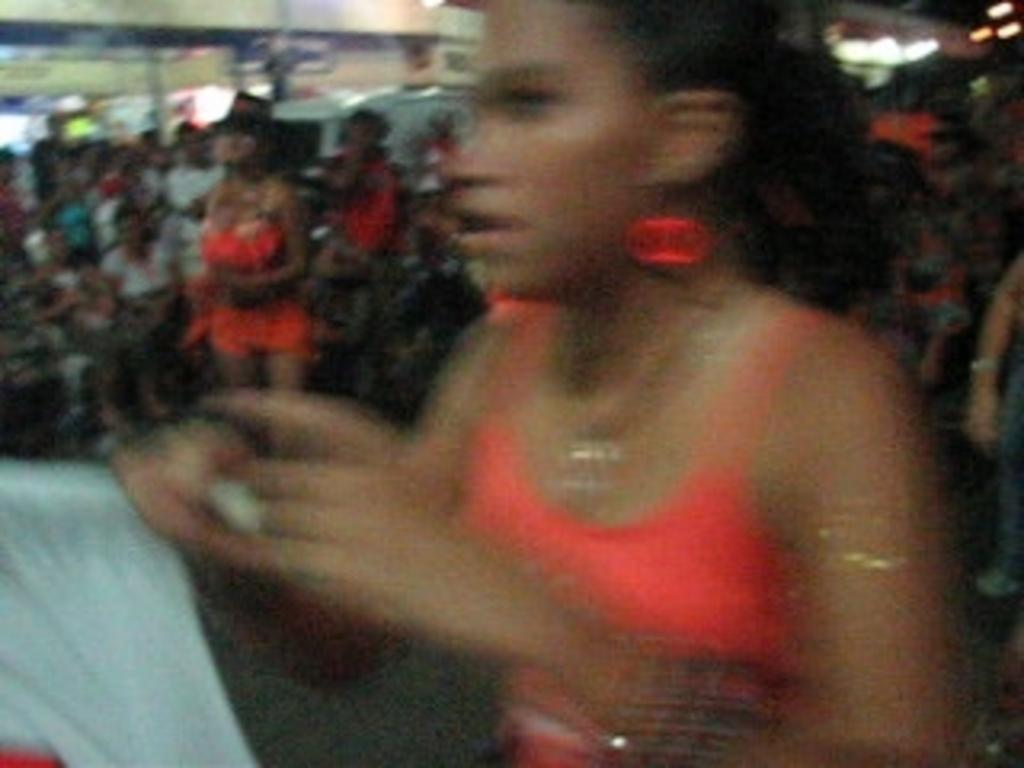What is the main subject of the image? The main subject of the image is a crowd. Where is the crowd located in the image? The crowd is on the floor. What else can be seen in the image besides the crowd? There are lights and buildings visible in the image. Can you tell if the image was taken during the day or night? The image may have been taken during the night, as there are lights visible. What shape of the birthday cake can be seen in the image? There is no birthday cake present in the image, so it is not possible to determine its shape. 